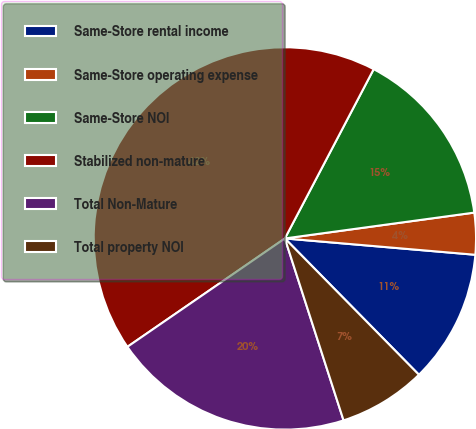<chart> <loc_0><loc_0><loc_500><loc_500><pie_chart><fcel>Same-Store rental income<fcel>Same-Store operating expense<fcel>Same-Store NOI<fcel>Stabilized non-mature<fcel>Total Non-Mature<fcel>Total property NOI<nl><fcel>11.27%<fcel>3.52%<fcel>15.15%<fcel>42.28%<fcel>20.37%<fcel>7.4%<nl></chart> 